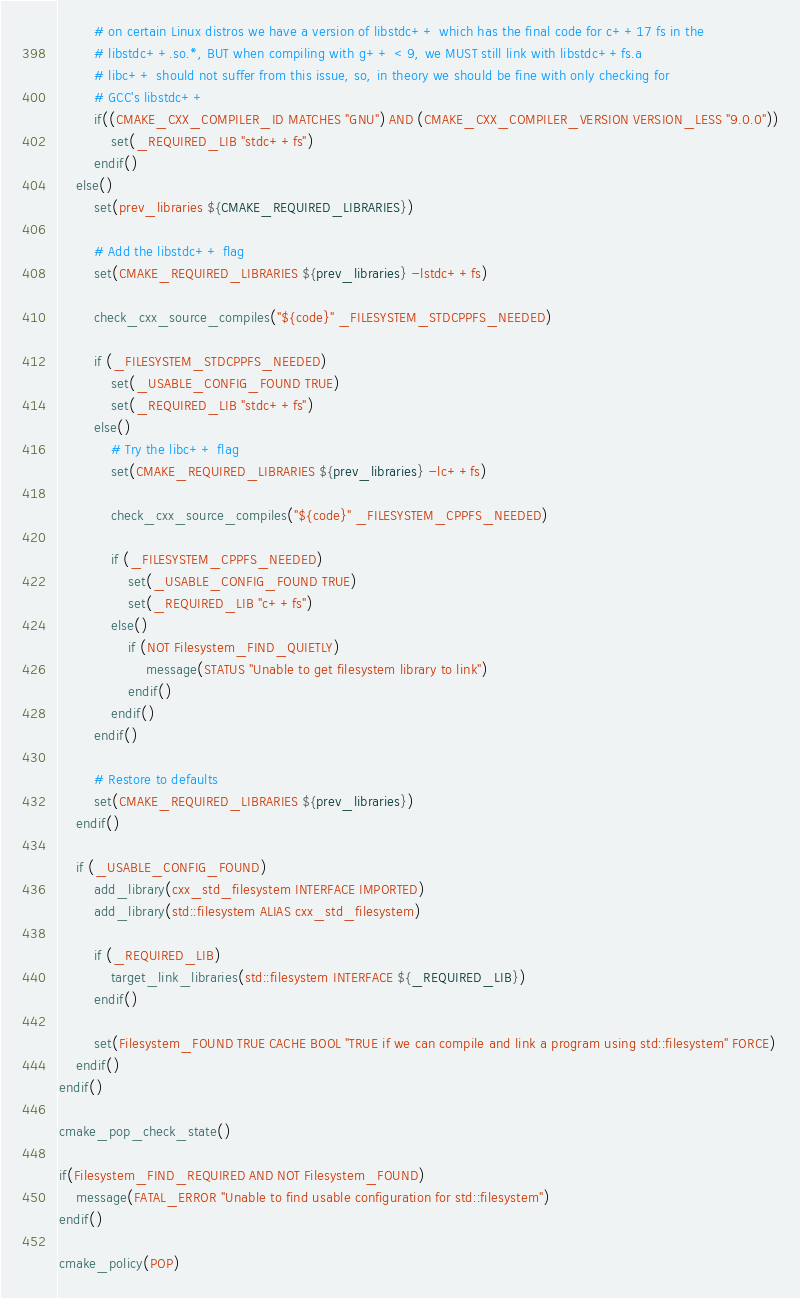<code> <loc_0><loc_0><loc_500><loc_500><_CMake_>		# on certain Linux distros we have a version of libstdc++ which has the final code for c++17 fs in the
		# libstdc++.so.*, BUT when compiling with g++ < 9, we MUST still link with libstdc++fs.a 
		# libc++ should not suffer from this issue, so, in theory we should be fine with only checking for
		# GCC's libstdc++ 
		if((CMAKE_CXX_COMPILER_ID MATCHES "GNU") AND (CMAKE_CXX_COMPILER_VERSION VERSION_LESS "9.0.0"))
			set(_REQUIRED_LIB "stdc++fs")
		endif()
	else()
		set(prev_libraries ${CMAKE_REQUIRED_LIBRARIES})

		# Add the libstdc++ flag
		set(CMAKE_REQUIRED_LIBRARIES ${prev_libraries} -lstdc++fs)

		check_cxx_source_compiles("${code}" _FILESYSTEM_STDCPPFS_NEEDED)

		if (_FILESYSTEM_STDCPPFS_NEEDED)
			set(_USABLE_CONFIG_FOUND TRUE)
			set(_REQUIRED_LIB "stdc++fs")
		else()
			# Try the libc++ flag
			set(CMAKE_REQUIRED_LIBRARIES ${prev_libraries} -lc++fs)

			check_cxx_source_compiles("${code}" _FILESYSTEM_CPPFS_NEEDED)

			if (_FILESYSTEM_CPPFS_NEEDED)
				set(_USABLE_CONFIG_FOUND TRUE)
				set(_REQUIRED_LIB "c++fs")
			else()
				if (NOT Filesystem_FIND_QUIETLY)
					message(STATUS "Unable to get filesystem library to link")
				endif()
			endif()
		endif()

		# Restore to defaults
		set(CMAKE_REQUIRED_LIBRARIES ${prev_libraries})
	endif()

	if (_USABLE_CONFIG_FOUND)
		add_library(cxx_std_filesystem INTERFACE IMPORTED)
		add_library(std::filesystem ALIAS cxx_std_filesystem)

		if (_REQUIRED_LIB)
			target_link_libraries(std::filesystem INTERFACE ${_REQUIRED_LIB})
		endif()

		set(Filesystem_FOUND TRUE CACHE BOOL "TRUE if we can compile and link a program using std::filesystem" FORCE)
	endif()
endif()

cmake_pop_check_state()

if(Filesystem_FIND_REQUIRED AND NOT Filesystem_FOUND)
	message(FATAL_ERROR "Unable to find usable configuration for std::filesystem")
endif()

cmake_policy(POP)
</code> 